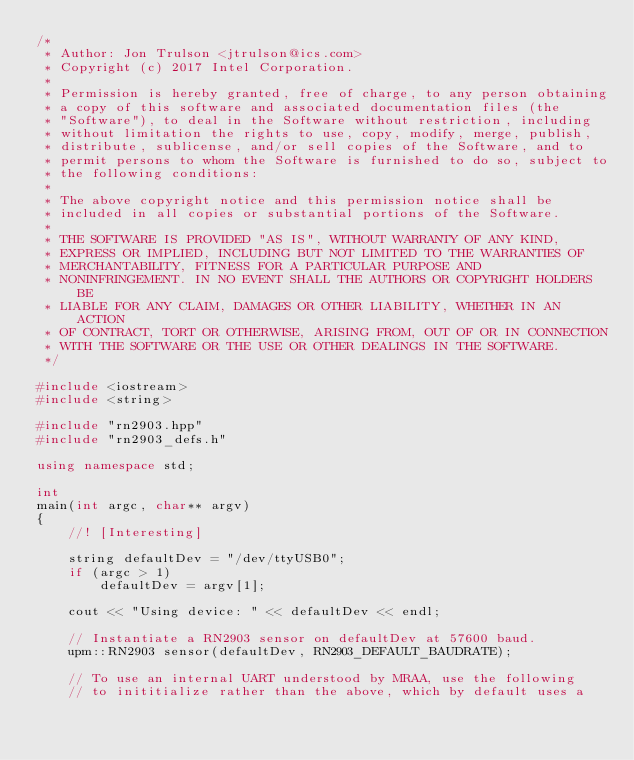<code> <loc_0><loc_0><loc_500><loc_500><_C++_>/*
 * Author: Jon Trulson <jtrulson@ics.com>
 * Copyright (c) 2017 Intel Corporation.
 *
 * Permission is hereby granted, free of charge, to any person obtaining
 * a copy of this software and associated documentation files (the
 * "Software"), to deal in the Software without restriction, including
 * without limitation the rights to use, copy, modify, merge, publish,
 * distribute, sublicense, and/or sell copies of the Software, and to
 * permit persons to whom the Software is furnished to do so, subject to
 * the following conditions:
 *
 * The above copyright notice and this permission notice shall be
 * included in all copies or substantial portions of the Software.
 *
 * THE SOFTWARE IS PROVIDED "AS IS", WITHOUT WARRANTY OF ANY KIND,
 * EXPRESS OR IMPLIED, INCLUDING BUT NOT LIMITED TO THE WARRANTIES OF
 * MERCHANTABILITY, FITNESS FOR A PARTICULAR PURPOSE AND
 * NONINFRINGEMENT. IN NO EVENT SHALL THE AUTHORS OR COPYRIGHT HOLDERS BE
 * LIABLE FOR ANY CLAIM, DAMAGES OR OTHER LIABILITY, WHETHER IN AN ACTION
 * OF CONTRACT, TORT OR OTHERWISE, ARISING FROM, OUT OF OR IN CONNECTION
 * WITH THE SOFTWARE OR THE USE OR OTHER DEALINGS IN THE SOFTWARE.
 */

#include <iostream>
#include <string>

#include "rn2903.hpp"
#include "rn2903_defs.h"

using namespace std;

int
main(int argc, char** argv)
{
    //! [Interesting]

    string defaultDev = "/dev/ttyUSB0";
    if (argc > 1)
        defaultDev = argv[1];

    cout << "Using device: " << defaultDev << endl;

    // Instantiate a RN2903 sensor on defaultDev at 57600 baud.
    upm::RN2903 sensor(defaultDev, RN2903_DEFAULT_BAUDRATE);

    // To use an internal UART understood by MRAA, use the following
    // to inititialize rather than the above, which by default uses a</code> 